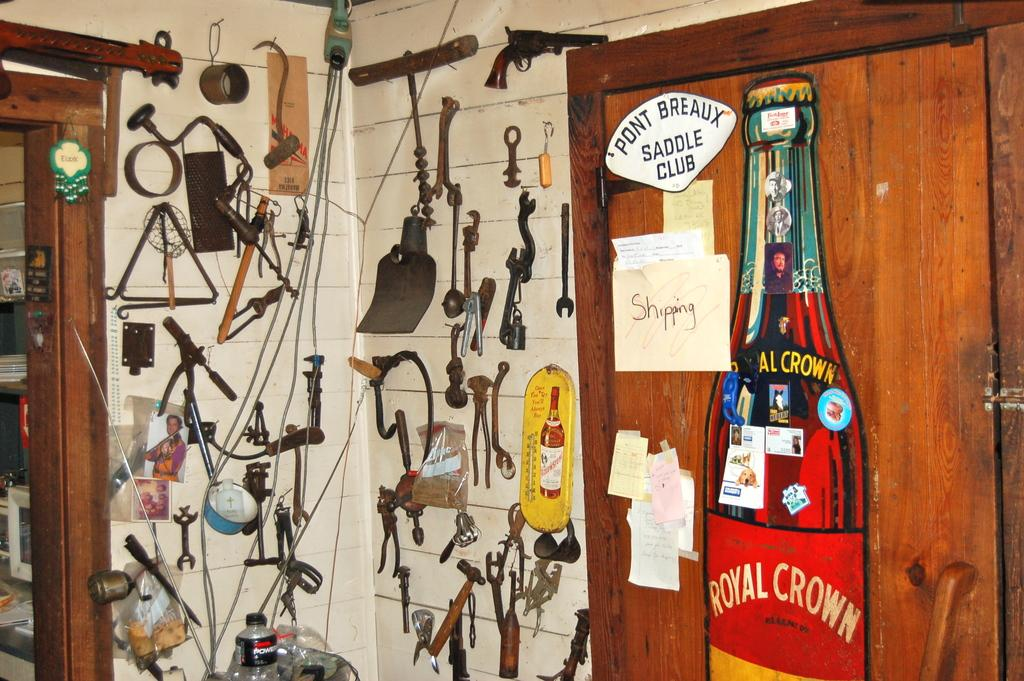<image>
Relay a brief, clear account of the picture shown. A room with a royal crown bottle poster hanging on a door and random knick knacks hanging on the walls 